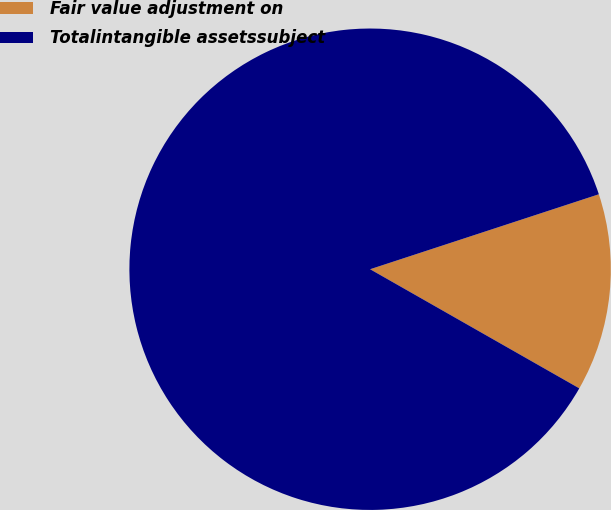Convert chart. <chart><loc_0><loc_0><loc_500><loc_500><pie_chart><fcel>Fair value adjustment on<fcel>Totalintangible assetssubject<nl><fcel>13.28%<fcel>86.72%<nl></chart> 